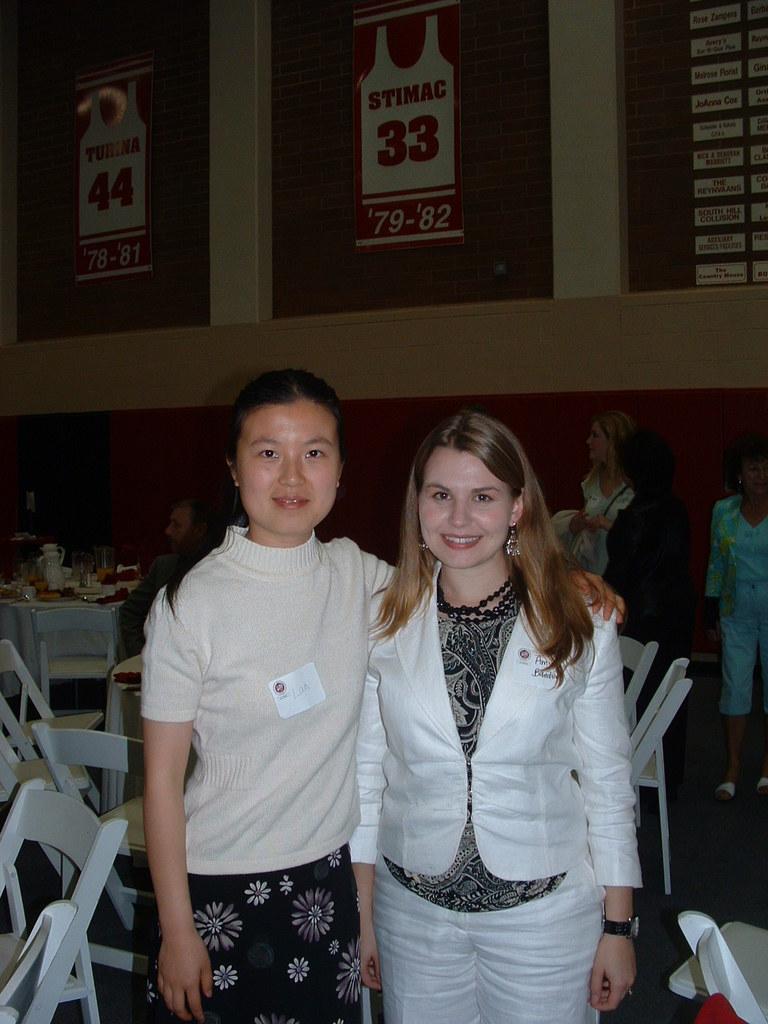Describe this image in one or two sentences. In this picture there are two girls in the center of the image and there are tables, chairs, and other people in the background area of the image and there are posters at the top side of the image. 